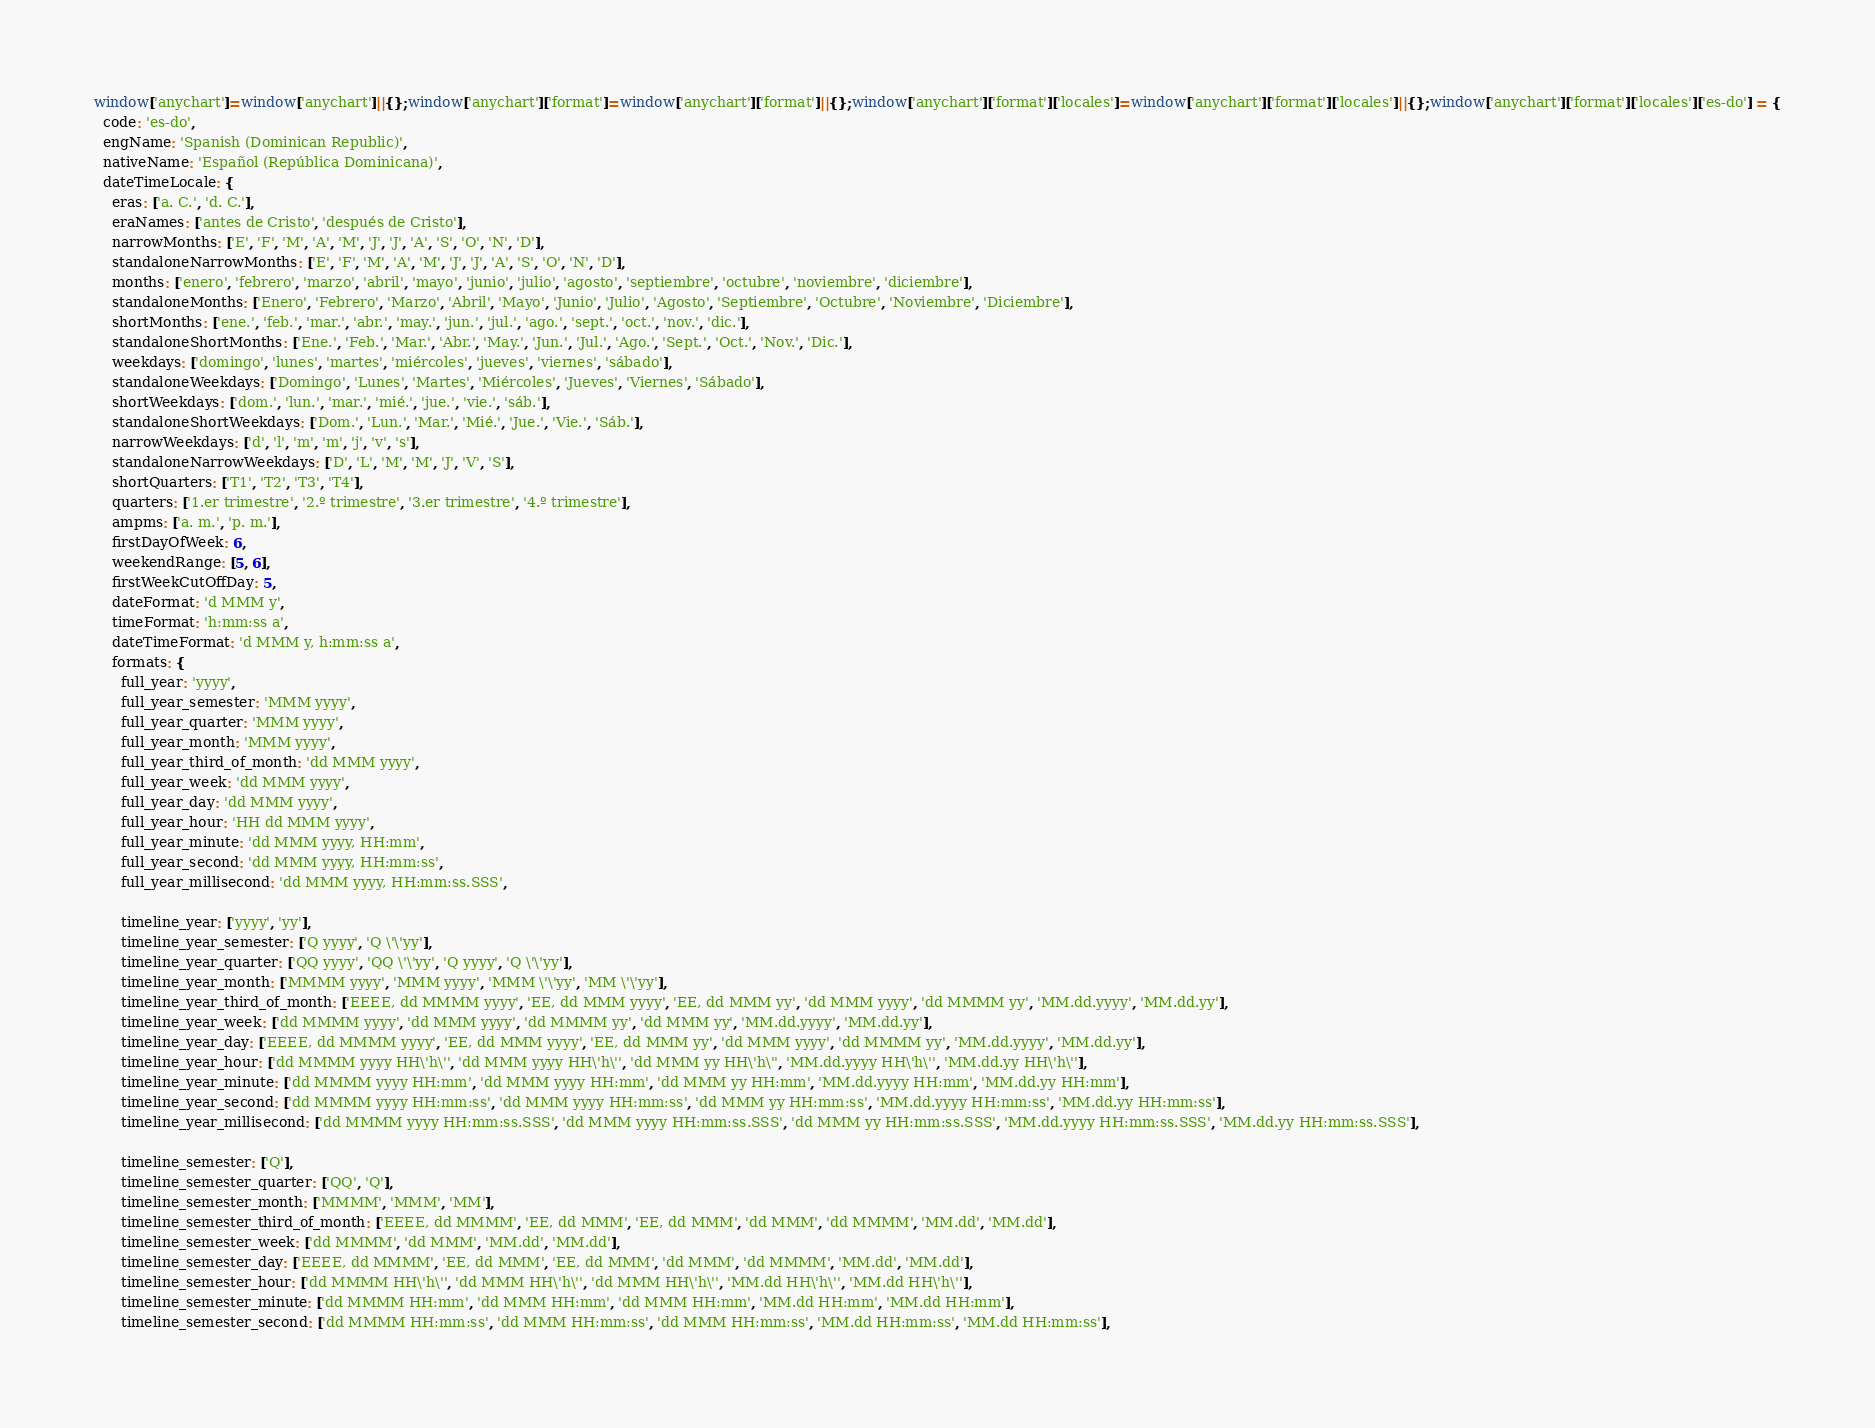<code> <loc_0><loc_0><loc_500><loc_500><_JavaScript_>window['anychart']=window['anychart']||{};window['anychart']['format']=window['anychart']['format']||{};window['anychart']['format']['locales']=window['anychart']['format']['locales']||{};window['anychart']['format']['locales']['es-do'] = {
  code: 'es-do',
  engName: 'Spanish (Dominican Republic)',
  nativeName: 'Español (República Dominicana)',
  dateTimeLocale: {
    eras: ['a. C.', 'd. C.'],
    eraNames: ['antes de Cristo', 'después de Cristo'],
    narrowMonths: ['E', 'F', 'M', 'A', 'M', 'J', 'J', 'A', 'S', 'O', 'N', 'D'],
    standaloneNarrowMonths: ['E', 'F', 'M', 'A', 'M', 'J', 'J', 'A', 'S', 'O', 'N', 'D'],
    months: ['enero', 'febrero', 'marzo', 'abril', 'mayo', 'junio', 'julio', 'agosto', 'septiembre', 'octubre', 'noviembre', 'diciembre'],
    standaloneMonths: ['Enero', 'Febrero', 'Marzo', 'Abril', 'Mayo', 'Junio', 'Julio', 'Agosto', 'Septiembre', 'Octubre', 'Noviembre', 'Diciembre'],
    shortMonths: ['ene.', 'feb.', 'mar.', 'abr.', 'may.', 'jun.', 'jul.', 'ago.', 'sept.', 'oct.', 'nov.', 'dic.'],
    standaloneShortMonths: ['Ene.', 'Feb.', 'Mar.', 'Abr.', 'May.', 'Jun.', 'Jul.', 'Ago.', 'Sept.', 'Oct.', 'Nov.', 'Dic.'],
    weekdays: ['domingo', 'lunes', 'martes', 'miércoles', 'jueves', 'viernes', 'sábado'],
    standaloneWeekdays: ['Domingo', 'Lunes', 'Martes', 'Miércoles', 'Jueves', 'Viernes', 'Sábado'],
    shortWeekdays: ['dom.', 'lun.', 'mar.', 'mié.', 'jue.', 'vie.', 'sáb.'],
    standaloneShortWeekdays: ['Dom.', 'Lun.', 'Mar.', 'Mié.', 'Jue.', 'Vie.', 'Sáb.'],
    narrowWeekdays: ['d', 'l', 'm', 'm', 'j', 'v', 's'],
    standaloneNarrowWeekdays: ['D', 'L', 'M', 'M', 'J', 'V', 'S'],
    shortQuarters: ['T1', 'T2', 'T3', 'T4'],
    quarters: ['1.er trimestre', '2.º trimestre', '3.er trimestre', '4.º trimestre'],
    ampms: ['a. m.', 'p. m.'],
    firstDayOfWeek: 6,
    weekendRange: [5, 6],
    firstWeekCutOffDay: 5,
    dateFormat: 'd MMM y',
    timeFormat: 'h:mm:ss a',
    dateTimeFormat: 'd MMM y, h:mm:ss a',
    formats: {
      full_year: 'yyyy',
      full_year_semester: 'MMM yyyy',
      full_year_quarter: 'MMM yyyy',
      full_year_month: 'MMM yyyy',
      full_year_third_of_month: 'dd MMM yyyy',
      full_year_week: 'dd MMM yyyy',
      full_year_day: 'dd MMM yyyy',
      full_year_hour: 'HH dd MMM yyyy',
      full_year_minute: 'dd MMM yyyy, HH:mm',
      full_year_second: 'dd MMM yyyy, HH:mm:ss',
      full_year_millisecond: 'dd MMM yyyy, HH:mm:ss.SSS',

      timeline_year: ['yyyy', 'yy'],
      timeline_year_semester: ['Q yyyy', 'Q \'\'yy'],
      timeline_year_quarter: ['QQ yyyy', 'QQ \'\'yy', 'Q yyyy', 'Q \'\'yy'],
      timeline_year_month: ['MMMM yyyy', 'MMM yyyy', 'MMM \'\'yy', 'MM \'\'yy'],
      timeline_year_third_of_month: ['EEEE, dd MMMM yyyy', 'EE, dd MMM yyyy', 'EE, dd MMM yy', 'dd MMM yyyy', 'dd MMMM yy', 'MM.dd.yyyy', 'MM.dd.yy'],
      timeline_year_week: ['dd MMMM yyyy', 'dd MMM yyyy', 'dd MMMM yy', 'dd MMM yy', 'MM.dd.yyyy', 'MM.dd.yy'],
      timeline_year_day: ['EEEE, dd MMMM yyyy', 'EE, dd MMM yyyy', 'EE, dd MMM yy', 'dd MMM yyyy', 'dd MMMM yy', 'MM.dd.yyyy', 'MM.dd.yy'],
      timeline_year_hour: ['dd MMMM yyyy HH\'h\'', 'dd MMM yyyy HH\'h\'', 'dd MMM yy HH\'h\'', 'MM.dd.yyyy HH\'h\'', 'MM.dd.yy HH\'h\''],
      timeline_year_minute: ['dd MMMM yyyy HH:mm', 'dd MMM yyyy HH:mm', 'dd MMM yy HH:mm', 'MM.dd.yyyy HH:mm', 'MM.dd.yy HH:mm'],
      timeline_year_second: ['dd MMMM yyyy HH:mm:ss', 'dd MMM yyyy HH:mm:ss', 'dd MMM yy HH:mm:ss', 'MM.dd.yyyy HH:mm:ss', 'MM.dd.yy HH:mm:ss'],
      timeline_year_millisecond: ['dd MMMM yyyy HH:mm:ss.SSS', 'dd MMM yyyy HH:mm:ss.SSS', 'dd MMM yy HH:mm:ss.SSS', 'MM.dd.yyyy HH:mm:ss.SSS', 'MM.dd.yy HH:mm:ss.SSS'],

      timeline_semester: ['Q'],
      timeline_semester_quarter: ['QQ', 'Q'],
      timeline_semester_month: ['MMMM', 'MMM', 'MM'],
      timeline_semester_third_of_month: ['EEEE, dd MMMM', 'EE, dd MMM', 'EE, dd MMM', 'dd MMM', 'dd MMMM', 'MM.dd', 'MM.dd'],
      timeline_semester_week: ['dd MMMM', 'dd MMM', 'MM.dd', 'MM.dd'],
      timeline_semester_day: ['EEEE, dd MMMM', 'EE, dd MMM', 'EE, dd MMM', 'dd MMM', 'dd MMMM', 'MM.dd', 'MM.dd'],
      timeline_semester_hour: ['dd MMMM HH\'h\'', 'dd MMM HH\'h\'', 'dd MMM HH\'h\'', 'MM.dd HH\'h\'', 'MM.dd HH\'h\''],
      timeline_semester_minute: ['dd MMMM HH:mm', 'dd MMM HH:mm', 'dd MMM HH:mm', 'MM.dd HH:mm', 'MM.dd HH:mm'],
      timeline_semester_second: ['dd MMMM HH:mm:ss', 'dd MMM HH:mm:ss', 'dd MMM HH:mm:ss', 'MM.dd HH:mm:ss', 'MM.dd HH:mm:ss'],</code> 